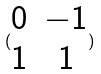Convert formula to latex. <formula><loc_0><loc_0><loc_500><loc_500>( \begin{matrix} 0 & - 1 \\ 1 & 1 \end{matrix} )</formula> 